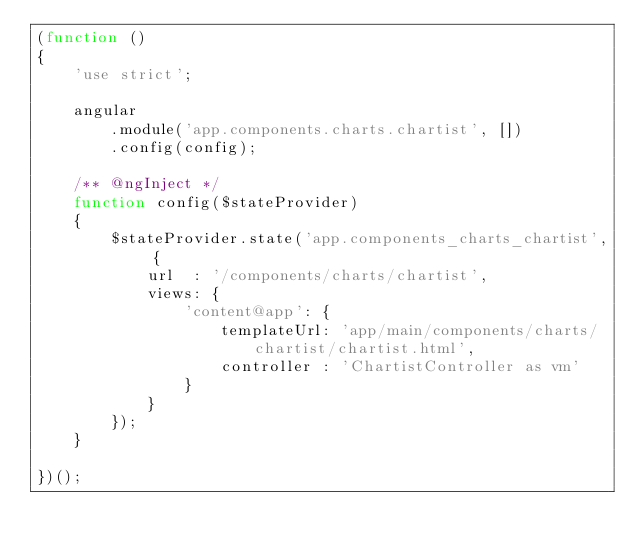<code> <loc_0><loc_0><loc_500><loc_500><_JavaScript_>(function ()
{
    'use strict';

    angular
        .module('app.components.charts.chartist', [])
        .config(config);

    /** @ngInject */
    function config($stateProvider)
    {
        $stateProvider.state('app.components_charts_chartist', {
            url  : '/components/charts/chartist',
            views: {
                'content@app': {
                    templateUrl: 'app/main/components/charts/chartist/chartist.html',
                    controller : 'ChartistController as vm'
                }
            }
        });
    }

})();</code> 